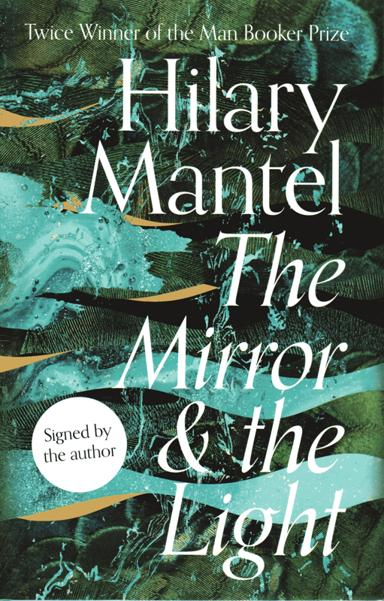What is the significance of the Man Booker Prize? The Man Booker Prize, now known simply as The Booker Prize, is one of the foremost awards for high-calibre literature written in English. Awarded each year in the UK, it highlights exceptional novels and brings them to global attention. Winning this prize is a career-defining moment for authors and often leads to international fame and substantially increased book sales. Hilary Mantel's dual victories underscore her exceptional skill in crafting engaging historical narratives. 